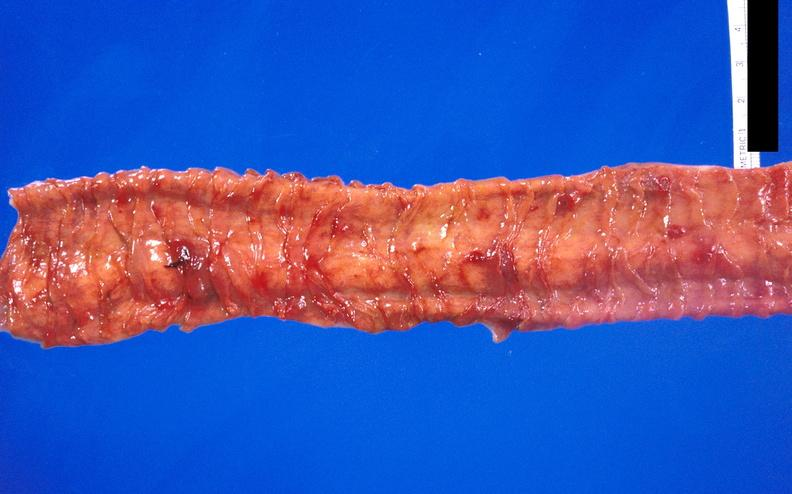s gastrointestinal present?
Answer the question using a single word or phrase. Yes 